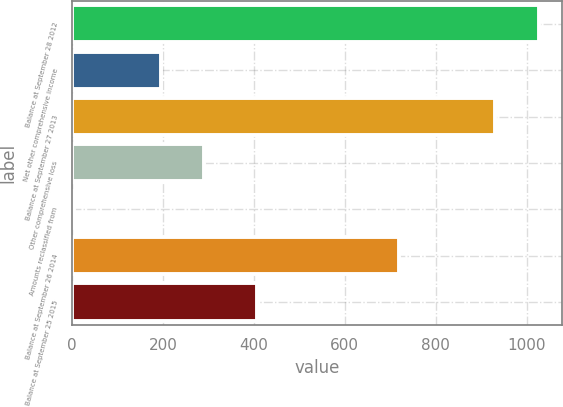Convert chart to OTSL. <chart><loc_0><loc_0><loc_500><loc_500><bar_chart><fcel>Balance at September 28 2012<fcel>Net other comprehensive income<fcel>Balance at September 27 2013<fcel>Other comprehensive loss<fcel>Amounts reclassified from<fcel>Balance at September 26 2014<fcel>Balance at September 25 2015<nl><fcel>1026.4<fcel>195.8<fcel>931<fcel>291.2<fcel>5<fcel>720<fcel>408<nl></chart> 